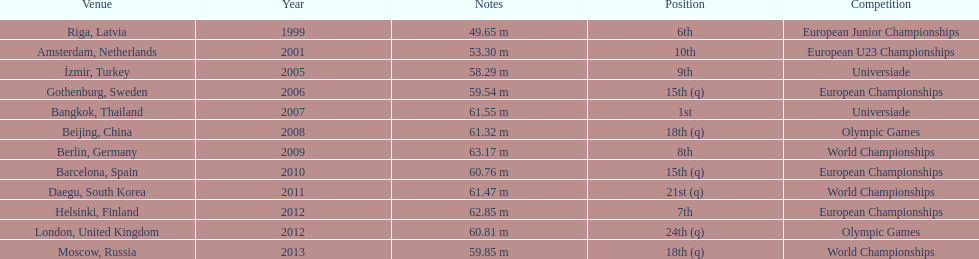What was the last competition he was in before the 2012 olympics? European Championships. 